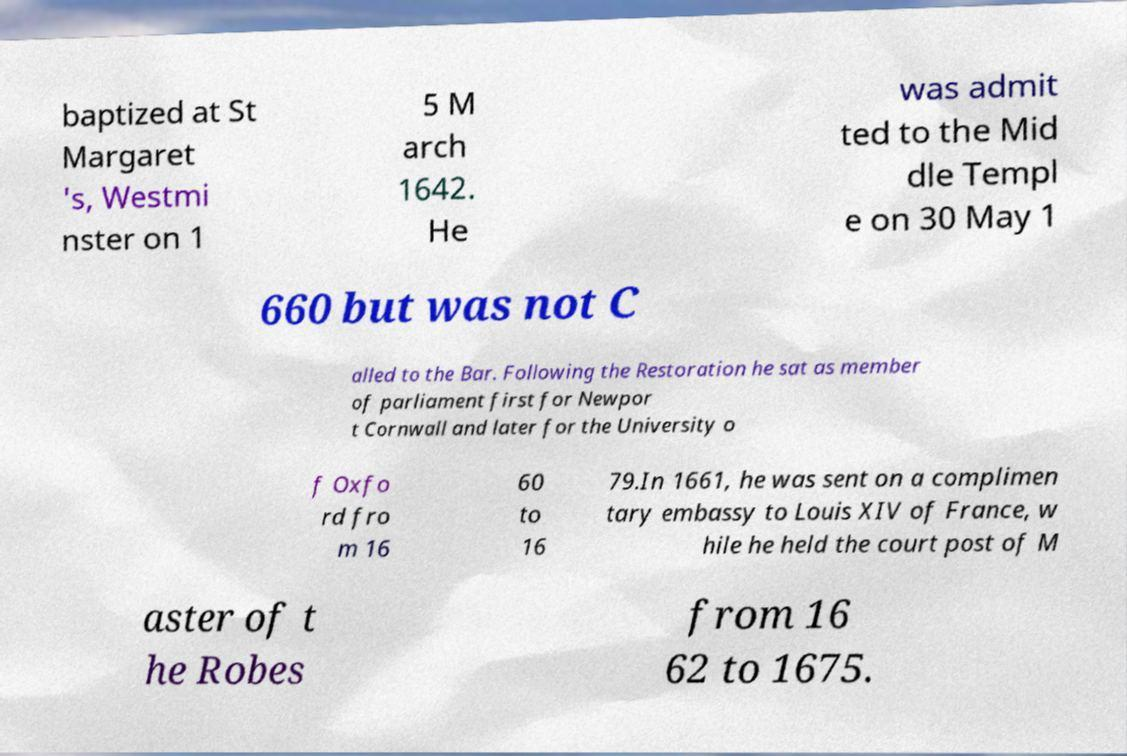There's text embedded in this image that I need extracted. Can you transcribe it verbatim? baptized at St Margaret 's, Westmi nster on 1 5 M arch 1642. He was admit ted to the Mid dle Templ e on 30 May 1 660 but was not C alled to the Bar. Following the Restoration he sat as member of parliament first for Newpor t Cornwall and later for the University o f Oxfo rd fro m 16 60 to 16 79.In 1661, he was sent on a complimen tary embassy to Louis XIV of France, w hile he held the court post of M aster of t he Robes from 16 62 to 1675. 